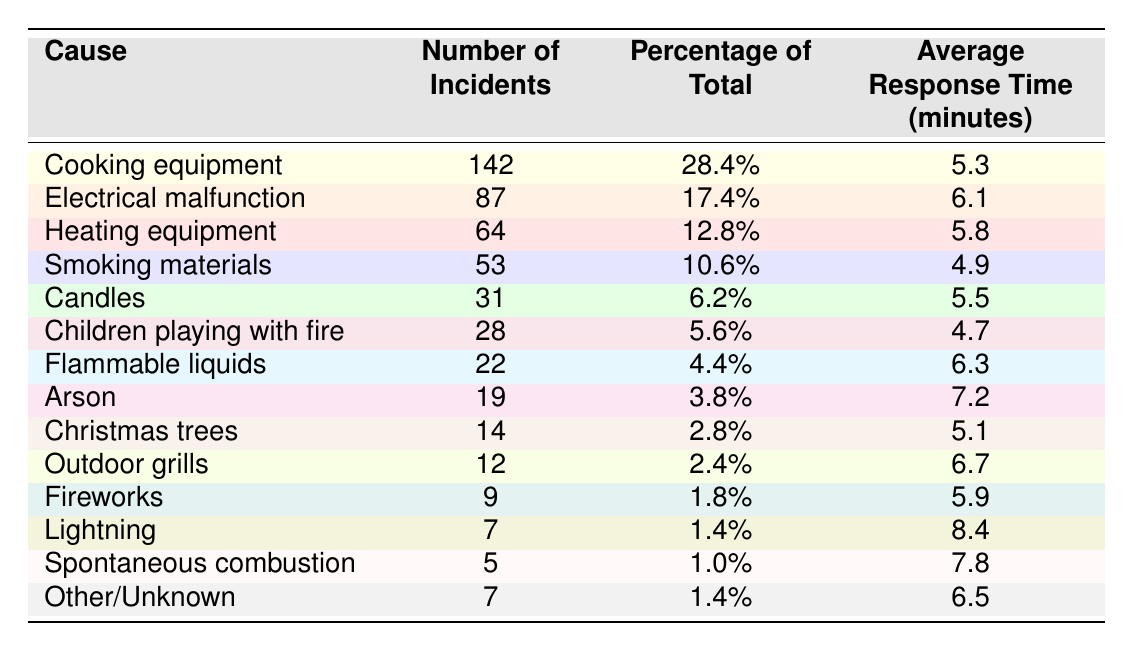What was the most common cause of residential fires last year? The most common cause of residential fires is listed as "Cooking equipment," which has 142 incidents.
Answer: Cooking equipment What percentage of residential fires were caused by electrical malfunctions? The table states that electrical malfunctions caused 87 incidents, which corresponds to 17.4% of total incidents reported.
Answer: 17.4% How many total incidents were attributed to smoking materials and candles combined? Adding incidents from smoking materials (53) and candles (31), we get 53 + 31 = 84.
Answer: 84 What was the average response time for fires caused by arson? The table lists the average response time for arson incidents as 7.2 minutes.
Answer: 7.2 minutes Which cause of residential fires had the highest average response time? By comparing the average response times, "Lightning" had the highest average response time at 8.4 minutes.
Answer: Lightning Is it true that the number of incidents caused by outdoor grills is less than those caused by fireworks? Outdoor grills caused 12 incidents while fireworks caused 9, hence, it is false that outdoor grills had fewer incidents.
Answer: False What is the total number of incidents for all causes? Summing all the incidents: 142 + 87 + 64 + 53 + 31 + 28 + 22 + 19 + 14 + 12 + 9 + 7 + 5 + 7 = 489.
Answer: 489 If we exclude the top two causes, what would be the total number of incidents from the remaining causes? Excluding the top two (Cooking equipment and Electrical malfunction), the total is 489 - (142 + 87) = 260 incidents from the remaining causes.
Answer: 260 What percentage of total incidents was contributed by "Children playing with fire"? According to the table, "Children playing with fire" corresponds to 28 incidents, amounting to 5.6% of total incidents.
Answer: 5.6% What can we infer about the dangers of cooking equipment compared to smoking materials in terms of incidents? Cooking equipment has the highest number of incidents (142) compared to smoking materials (53), indicating that cooking poses a greater risk in causing residential fires.
Answer: Cooking equipment is a greater risk 